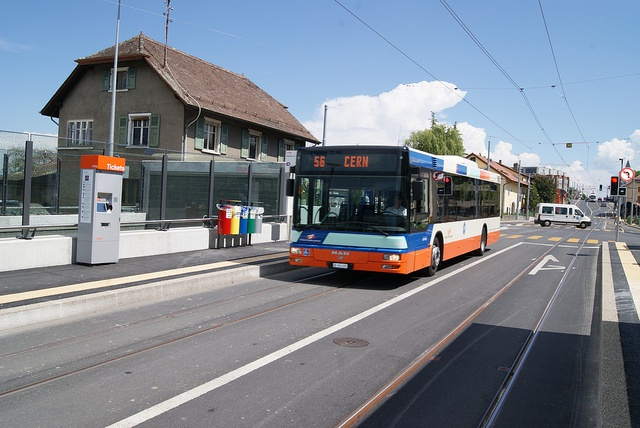Describe the objects in this image and their specific colors. I can see bus in gray, black, white, and navy tones, truck in gray, lightgray, black, and darkgray tones, traffic light in gray, black, darkgray, and red tones, traffic light in gray, black, darkgray, and purple tones, and car in gray and black tones in this image. 